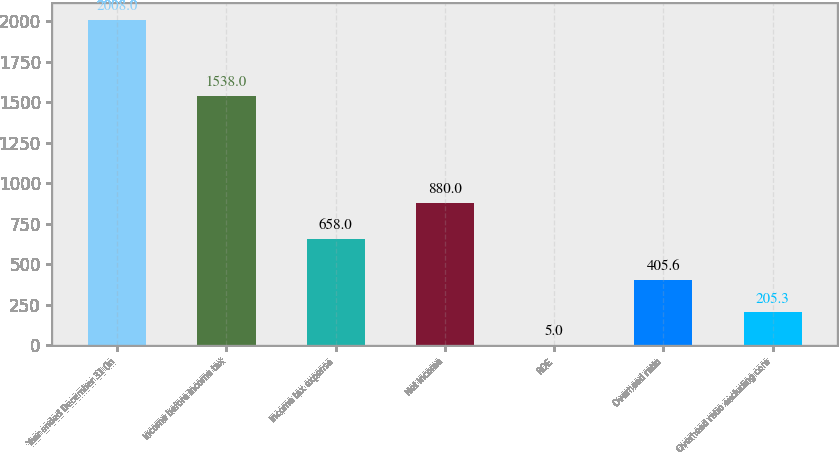Convert chart to OTSL. <chart><loc_0><loc_0><loc_500><loc_500><bar_chart><fcel>Year ended December 31 (in<fcel>Income before income tax<fcel>Income tax expense<fcel>Net income<fcel>ROE<fcel>Overhead ratio<fcel>Overhead ratio excluding core<nl><fcel>2008<fcel>1538<fcel>658<fcel>880<fcel>5<fcel>405.6<fcel>205.3<nl></chart> 